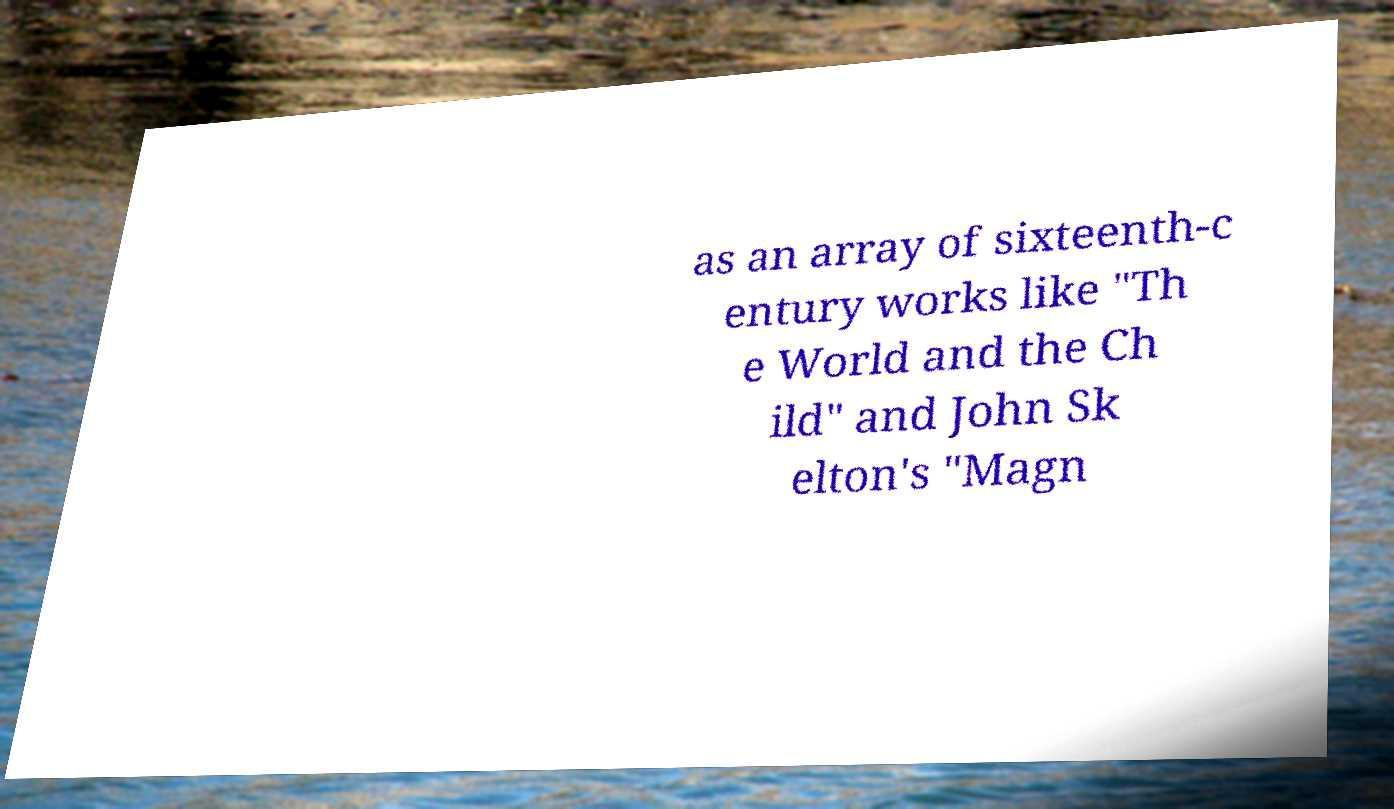Please read and relay the text visible in this image. What does it say? as an array of sixteenth-c entury works like "Th e World and the Ch ild" and John Sk elton's "Magn 